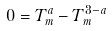Convert formula to latex. <formula><loc_0><loc_0><loc_500><loc_500>0 = T ^ { a } _ { m } - T ^ { 3 - a } _ { m }</formula> 